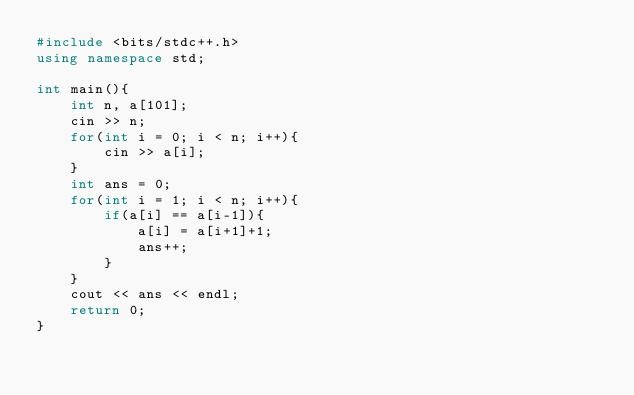Convert code to text. <code><loc_0><loc_0><loc_500><loc_500><_C++_>#include <bits/stdc++.h>
using namespace std;

int main(){
	int n, a[101];
	cin >> n;
	for(int i = 0; i < n; i++){
		cin >> a[i];
	}
	int ans = 0;
	for(int i = 1; i < n; i++){
		if(a[i] == a[i-1]){
			a[i] = a[i+1]+1;
			ans++;
		}
	}
	cout << ans << endl;
	return 0;
}</code> 